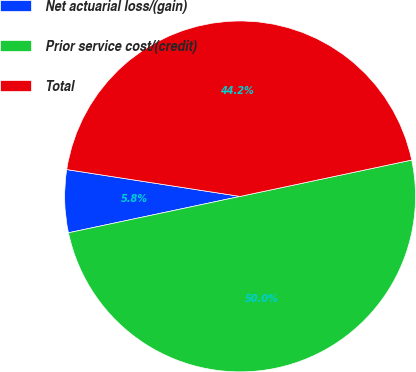Convert chart. <chart><loc_0><loc_0><loc_500><loc_500><pie_chart><fcel>Net actuarial loss/(gain)<fcel>Prior service cost/(credit)<fcel>Total<nl><fcel>5.77%<fcel>50.0%<fcel>44.23%<nl></chart> 